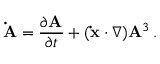Convert formula to latex. <formula><loc_0><loc_0><loc_500><loc_500>\dot { A } = { \frac { \partial A } { \partial t } } + ( \dot { x } \cdot \nabla ) A ^ { 3 } \, .</formula> 